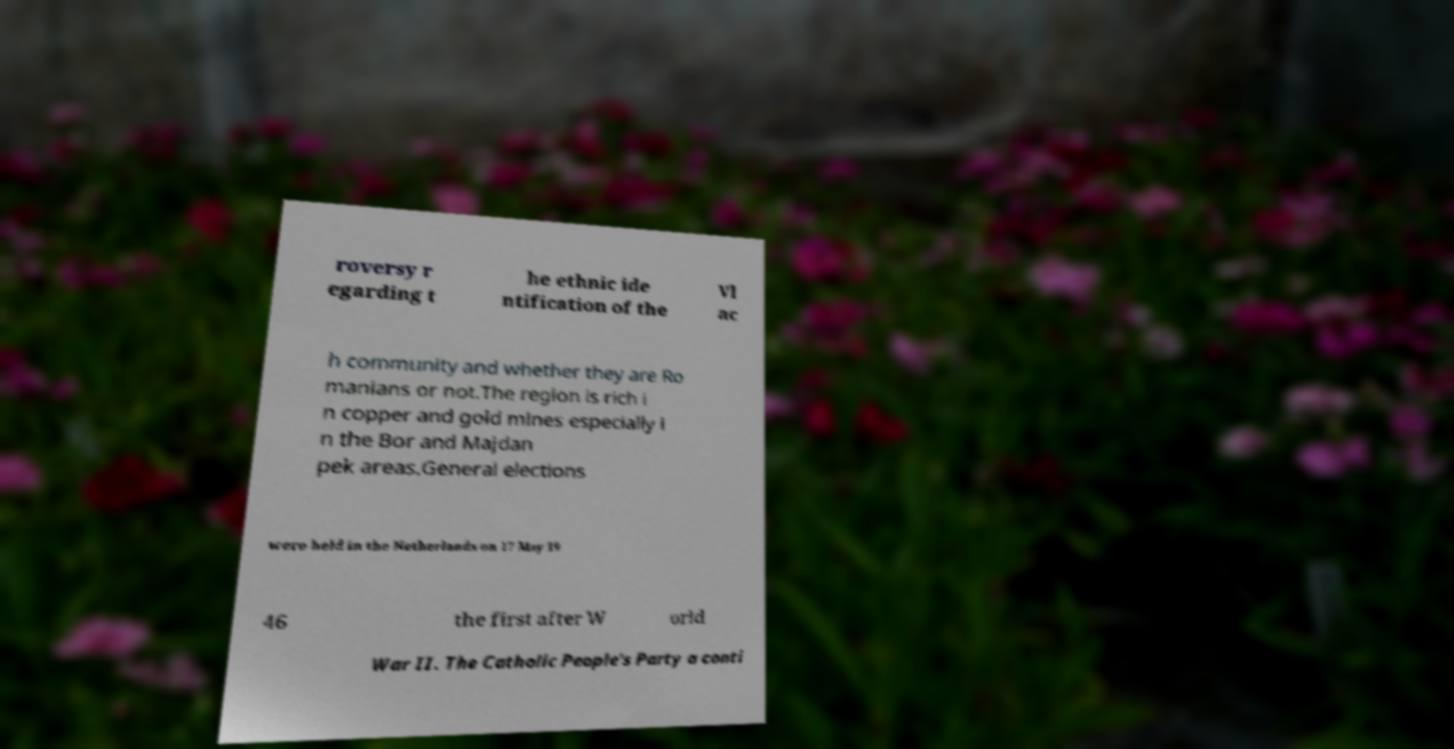Can you accurately transcribe the text from the provided image for me? roversy r egarding t he ethnic ide ntification of the Vl ac h community and whether they are Ro manians or not.The region is rich i n copper and gold mines especially i n the Bor and Majdan pek areas.General elections were held in the Netherlands on 17 May 19 46 the first after W orld War II. The Catholic People's Party a conti 